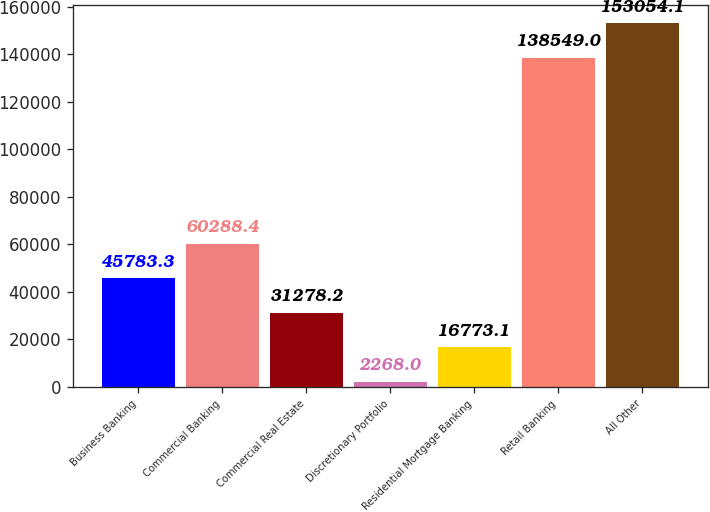<chart> <loc_0><loc_0><loc_500><loc_500><bar_chart><fcel>Business Banking<fcel>Commercial Banking<fcel>Commercial Real Estate<fcel>Discretionary Portfolio<fcel>Residential Mortgage Banking<fcel>Retail Banking<fcel>All Other<nl><fcel>45783.3<fcel>60288.4<fcel>31278.2<fcel>2268<fcel>16773.1<fcel>138549<fcel>153054<nl></chart> 